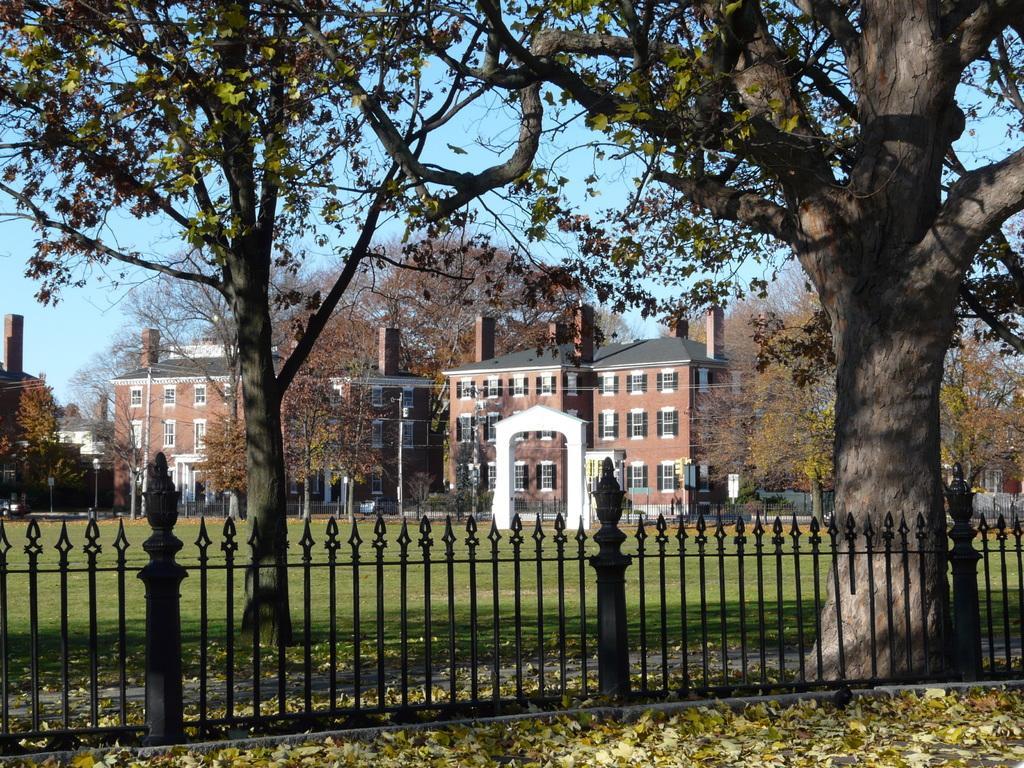Could you give a brief overview of what you see in this image? In this image there is fencing, trees, ground and houses. 